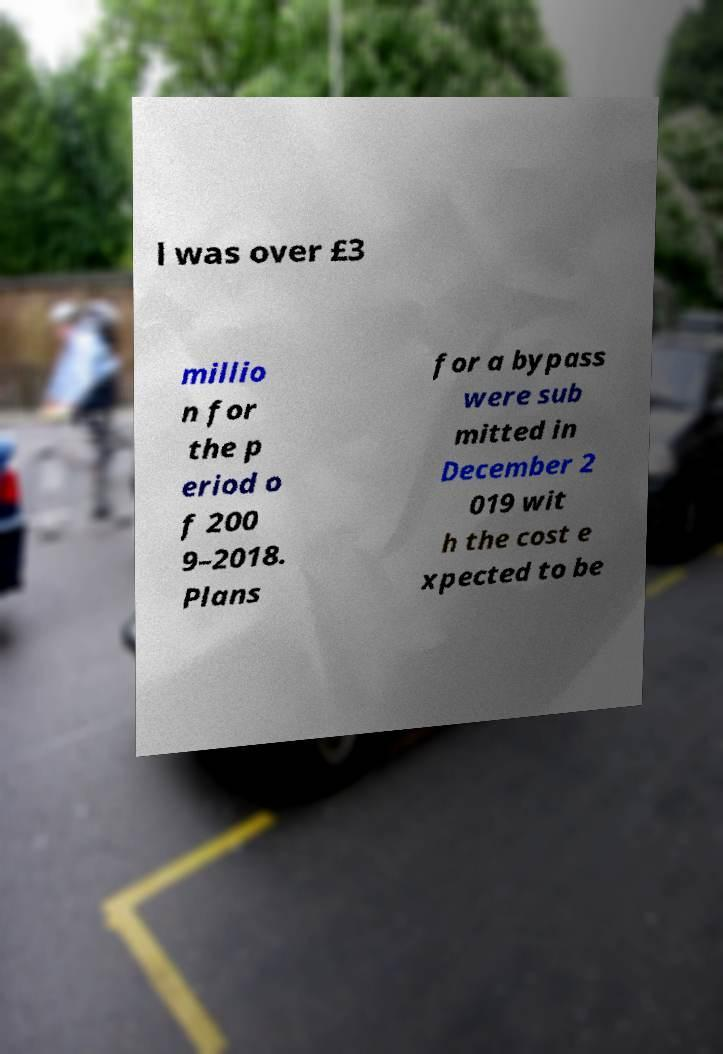Can you accurately transcribe the text from the provided image for me? l was over £3 millio n for the p eriod o f 200 9–2018. Plans for a bypass were sub mitted in December 2 019 wit h the cost e xpected to be 